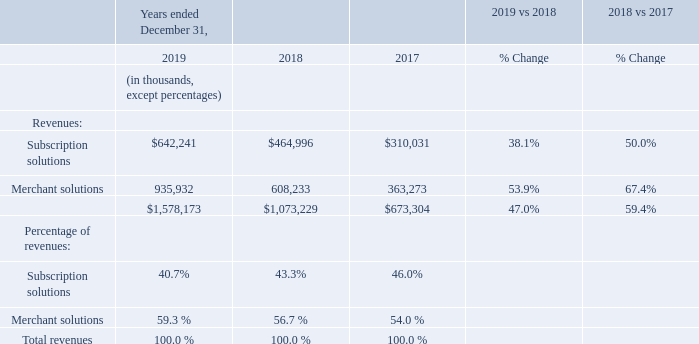Discussion of the Results of Operations for the years ended December 31, 2019, 2018, and 2017
Revenues
Subscription Solutions
Subscription solutions revenues increased $177.2 million, or 38.1%, for the year ended December 31, 2019 compared to the same period in 2018. Subscription solutions revenues increased $155.0 million, or 50.0%, for the year ended December 31, 2018 compared to the same period in 2017. The increase in both periods was primarily a result of growth in MRR driven by the higher number of merchants using our platform.
Merchant Solutions
Merchant solutions revenues increased $327.7 million, or 53.9%, for the year ended December 31, 2019 compared to the same period in 2018. The increase in merchant solutions revenues was primarily a result of Shopify Payments revenue growing by $239.6 million, or 53.3%, in 2019 compared to the same period in 2018. This increase was a result of an increase in the number of merchants using our platform, continued expansion into new geographical regions, and an increase in adoption of Shopify Payments by our merchants, which drove $9.1 billion of additional GMV facilitated using Shopify Payments in 2019 compared to the same period in 2018. For the year ended December 31, 2019, the Shopify Payments penetration rate was 42.1%, resulting in GMV of $25.7 billion that was facilitated using Shopify Payments. This compares to a penetration rate of 40.4%, resulting in GMV of $16.6 billion that was facilitated using Shopify Payments in the same period in 2018. As at December 31, 2019 Shopify Payments adoption among our merchants was as follows: United States, 91%; Canada, 90%; Australia, 89%; United Kingdom, 88%; Ireland, 84%; New Zealand, 76%; and other countries where Shopify Payments is available, 70%. Merchant solutions revenues increased $327.7 million, or 53.9%, for the year ended December 31, 2019 compared to the same period in 2018. The increase in merchant solutions revenues was primarily a result of Shopify Payments revenue growing by $239.6 million, or 53.3%, in 2019 compared to the same period in 2018. This increase was a result of an increase in the number of merchants using our platform, continued expansion into new geographical regions, and an increase in adoption of Shopify Payments by our merchants, which drove $9.1 billion of additional GMV facilitated using Shopify Payments in 2019 compared to the same period in 2018. For the year ended December 31, 2019, the Shopify Payments penetration rate was 42.1%, resulting in GMV of $25.7 billion that was facilitated using Shopify Payments. This compares to a penetration rate of 40.4%, resulting in GMV of $16.6 billion that was facilitated using Shopify Payments in the same period in 2018. As at December 31, 2019 Shopify Payments adoption among our merchants was as follows: United States, 91%; Canada, 90%; Australia, 89%; United Kingdom, 88%; Ireland, 84%; New Zealand, 76%; and other countries where Shopify Payments is available, 70%.
In addition to the increase in revenue from Shopify Payments, revenue from transaction fees, referral fees from partners, Shopify Capital, and Shopify Shipping increased during the year ended December 31, 2019 compared to the same period in 2018, as a result of the increase in GMV facilitated through our platform.
Merchant solutions revenues increased $245.0 million, or 67.4%, for the year ended December 31, 2018 compared to the same period in 2017. The increase in merchant solutions revenues was primarily a result of Shopify Payments revenue growing by $176.0 million, or 64.4%. Additionally, revenue from transaction fees, referral fees from partners, Shopify Capital, and Shopify Shipping increased for the year ended December 31, 2018 compared to the same period in 2017.
What is the total revenue for year ended December 31, 2019?
Answer scale should be: thousand. $1,578,173. What is the subscription solutions revenue for year ended December 31, 2019?
Answer scale should be: thousand. $642,241. What is the merchant solutions revenue for year ended December 31, 2019?
Answer scale should be: thousand. 935,932. Which year has the highest Subscription solutions revenues? 642,241> 464,996> 310,031
Answer: 2019. Which year has the highest Merchant solutions revenues? 935,932> 608,233> 363,273
Answer: 2019. What is the change in subscription solutions revenue between 2018 and 2019?
Answer scale should be: thousand. 642,241-464,996
Answer: 177245. 